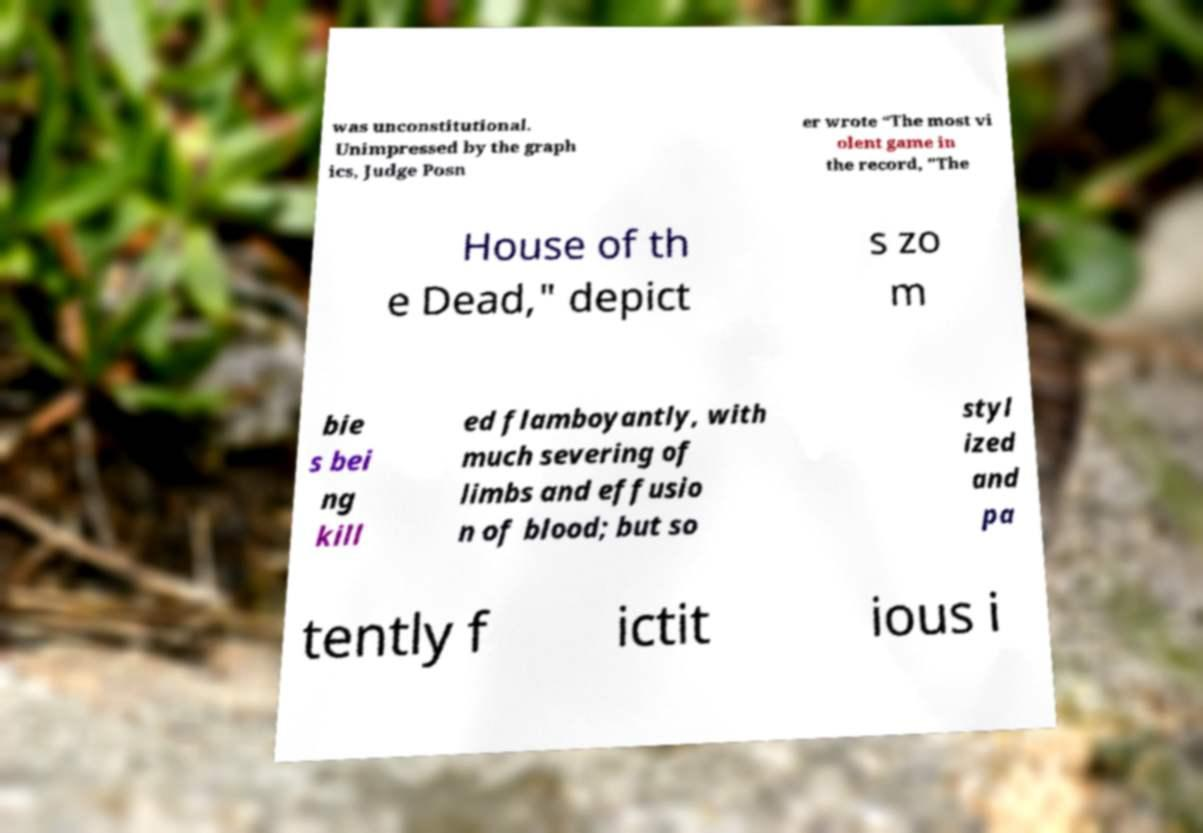What messages or text are displayed in this image? I need them in a readable, typed format. was unconstitutional. Unimpressed by the graph ics, Judge Posn er wrote “The most vi olent game in the record, "The House of th e Dead," depict s zo m bie s bei ng kill ed flamboyantly, with much severing of limbs and effusio n of blood; but so styl ized and pa tently f ictit ious i 